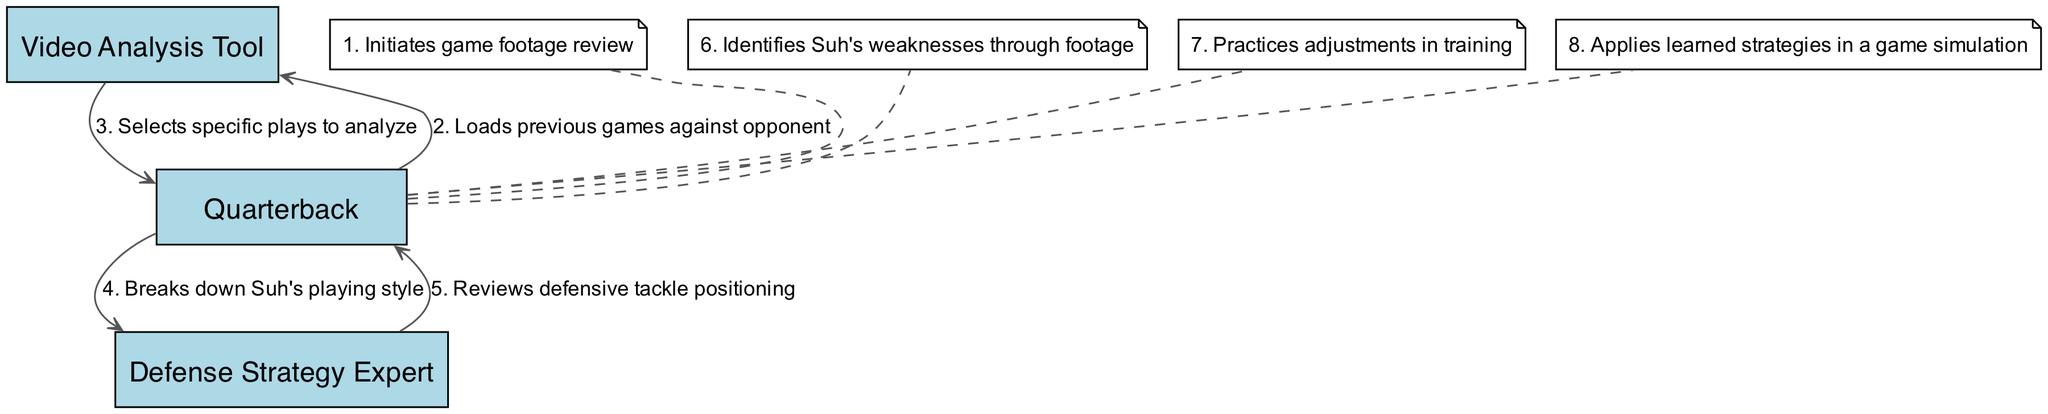What initiates the game footage review? The sequence starts with the Quarterback initiating the game footage review as the first action in the diagram. This is depicted by the first element in the sequence.
Answer: Quarterback How many actions does the Quarterback perform? By counting the actions listed in the diagram that are related to the Quarterback, we find that there are five actions attributed to the Quarterback: initiating the review, selecting plays, reviewing positioning, identifying weaknesses, and practicing adjustments.
Answer: Five Who analyzes Suh's playing style? The Defense Strategy Expert is the actor responsible for breaking down Suh's playing style, as highlighted in the corresponding action within the sequence.
Answer: Defense Strategy Expert What action comes after reviewing defensive tackle positioning? The action that follows reviewing defensive tackle positioning is the Quarterback identifying Suh's weaknesses through footage. This logic follows the flow of the sequence and can be traced from the positioning step to the weakness identification step.
Answer: Identifies Suh's weaknesses through footage Which actor applies learned strategies in a game simulation? The actor that applies learned strategies in a game simulation is again the Quarterback. This is the last action in the sequence, showing the culmination of the preparation steps taken prior.
Answer: Quarterback Which step precedes the Defense Strategy Expert's analysis? The step that comes just before the Defense Strategy Expert's analysis is the Quarterback's selection of specific plays to analyze. This shows a flow where the Quarterback first identifies what needs to be analyzed before the expert breakdown occurs.
Answer: Selects specific plays to analyze How many unique actors are represented in the diagram? The unique actors represented in the diagram include the Quarterback, Video Analysis Tool, and Defense Strategy Expert. Counting these actors provides a total of three unique participants in the sequence.
Answer: Three In which step does the Quarterback implement training adjustments? The step where the Quarterback practices adjustments in training follows the identification of Suh's weaknesses through footage, representing the application of learning before implementing in a game context.
Answer: Practices adjustments in training 